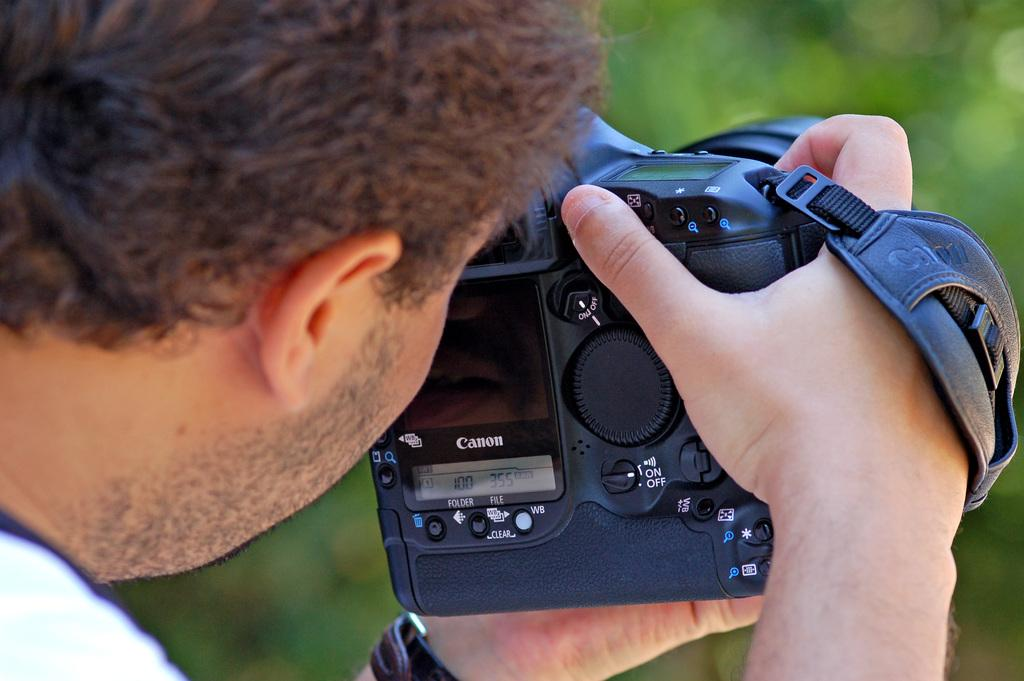What is the main subject of the image? The main subject of the image is a man. What is the man holding in the image? The man is holding a camera in the image. What brand of camera is the man holding? The camera is a Canon brand. What type of brass instrument is the man playing in the image? There is no brass instrument present in the image; the man is holding a camera. 